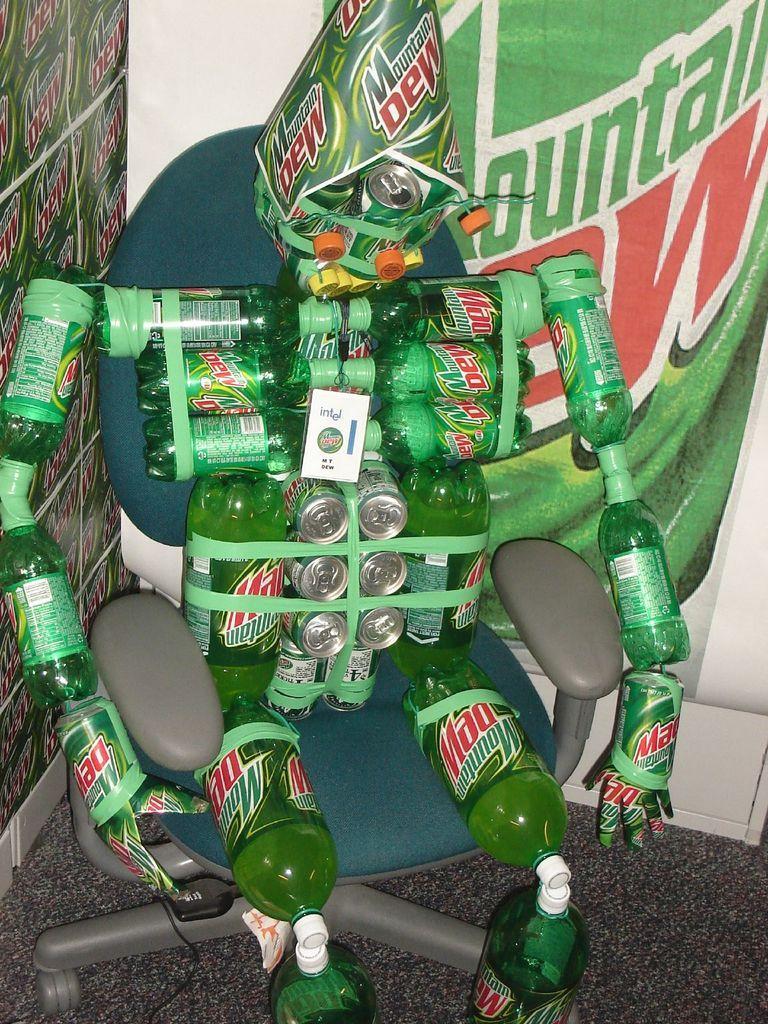In one or two sentences, can you explain what this image depicts? In this picture we can see a toy made with bottles and tins sitting on a chair. This is a floor. On the background we can see hoardings. 